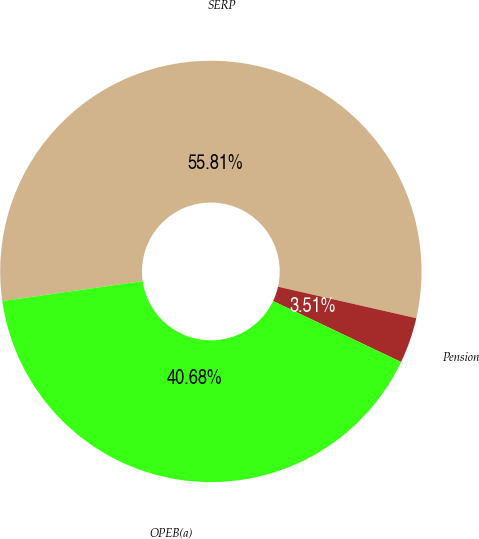<chart> <loc_0><loc_0><loc_500><loc_500><pie_chart><fcel>SERP<fcel>Pension<fcel>OPEB(a)<nl><fcel>55.81%<fcel>3.51%<fcel>40.68%<nl></chart> 